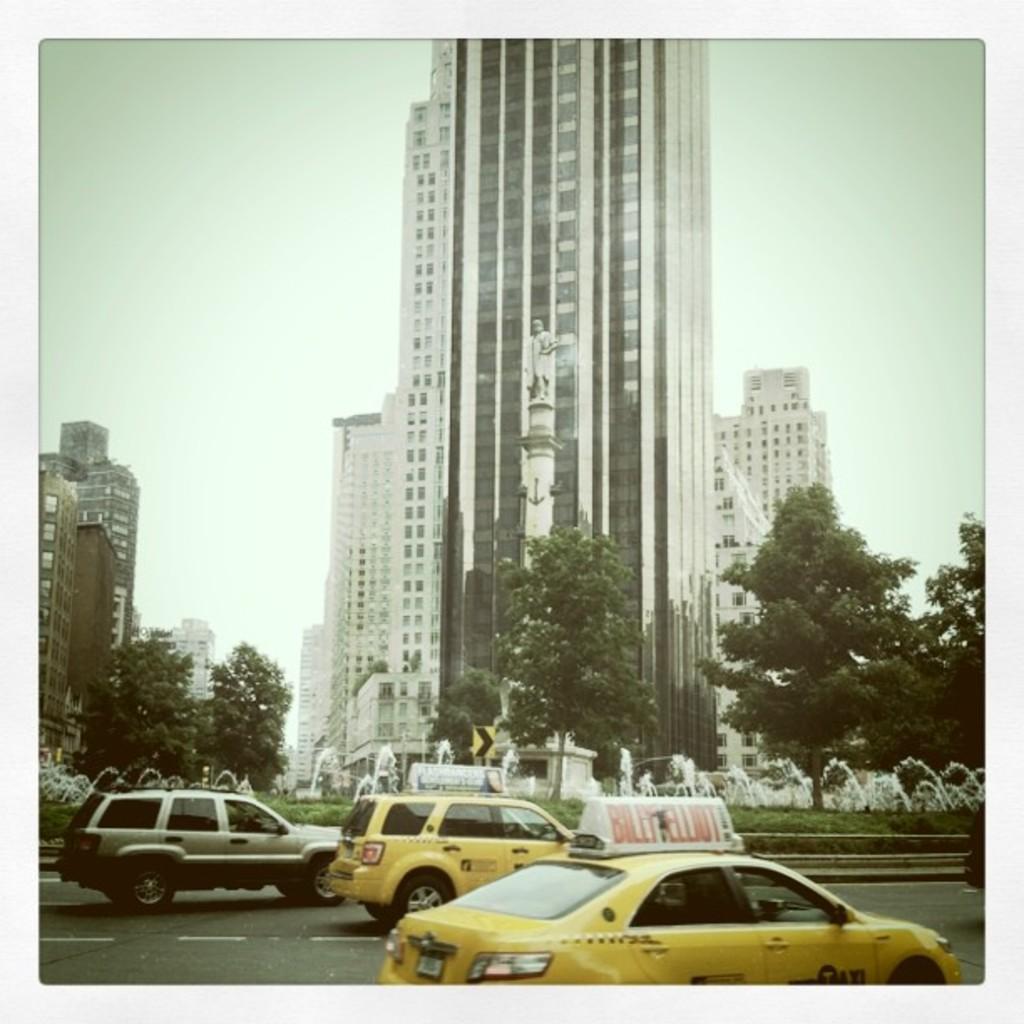Is that a billy elliot sign on top of that taxi?
Your answer should be very brief. Yes. What word is on the passenger side door of the yellow car?
Keep it short and to the point. Taxi. 